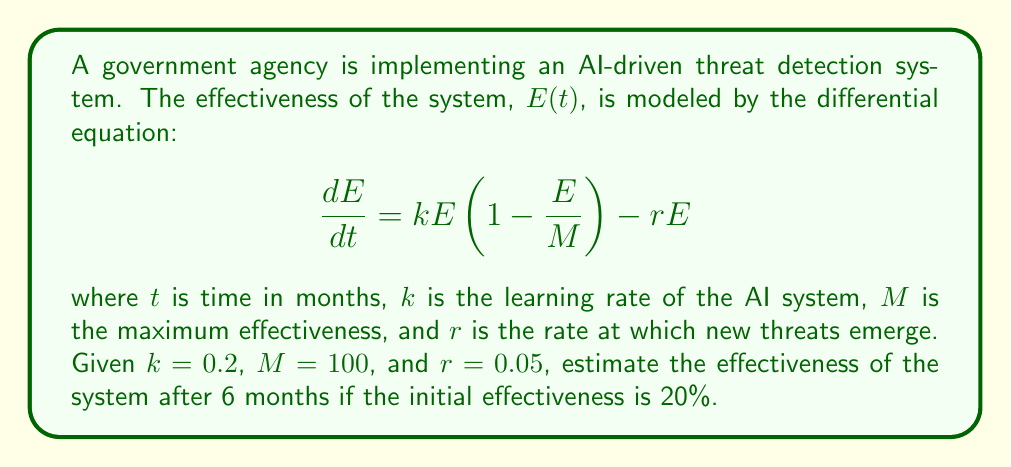Can you solve this math problem? To solve this problem, we need to use numerical methods to approximate the solution of the differential equation. We'll use Euler's method with a step size of 1 month.

1) First, let's rewrite the differential equation:

   $$\frac{dE}{dt} = 0.2E(1-\frac{E}{100}) - 0.05E = 0.2E - 0.002E^2 - 0.05E = 0.15E - 0.002E^2$$

2) Euler's method formula:

   $$E_{n+1} = E_n + h \cdot f(t_n, E_n)$$

   where $h$ is the step size (1 month in this case) and $f(t, E) = 0.15E - 0.002E^2$

3) Initial condition: $E_0 = 20$ (20% effectiveness)

4) Let's calculate for 6 steps:

   Step 1: $E_1 = 20 + 1 \cdot (0.15 \cdot 20 - 0.002 \cdot 20^2) = 22.2$
   Step 2: $E_2 = 22.2 + 1 \cdot (0.15 \cdot 22.2 - 0.002 \cdot 22.2^2) = 24.53$
   Step 3: $E_3 = 24.53 + 1 \cdot (0.15 \cdot 24.53 - 0.002 \cdot 24.53^2) = 26.95$
   Step 4: $E_4 = 26.95 + 1 \cdot (0.15 \cdot 26.95 - 0.002 \cdot 26.95^2) = 29.41$
   Step 5: $E_5 = 29.41 + 1 \cdot (0.15 \cdot 29.41 - 0.002 \cdot 29.41^2) = 31.86$
   Step 6: $E_6 = 31.86 + 1 \cdot (0.15 \cdot 31.86 - 0.002 \cdot 31.86^2) = 34.26$

5) Therefore, after 6 months, the estimated effectiveness is approximately 34.26%.
Answer: 34.26% 